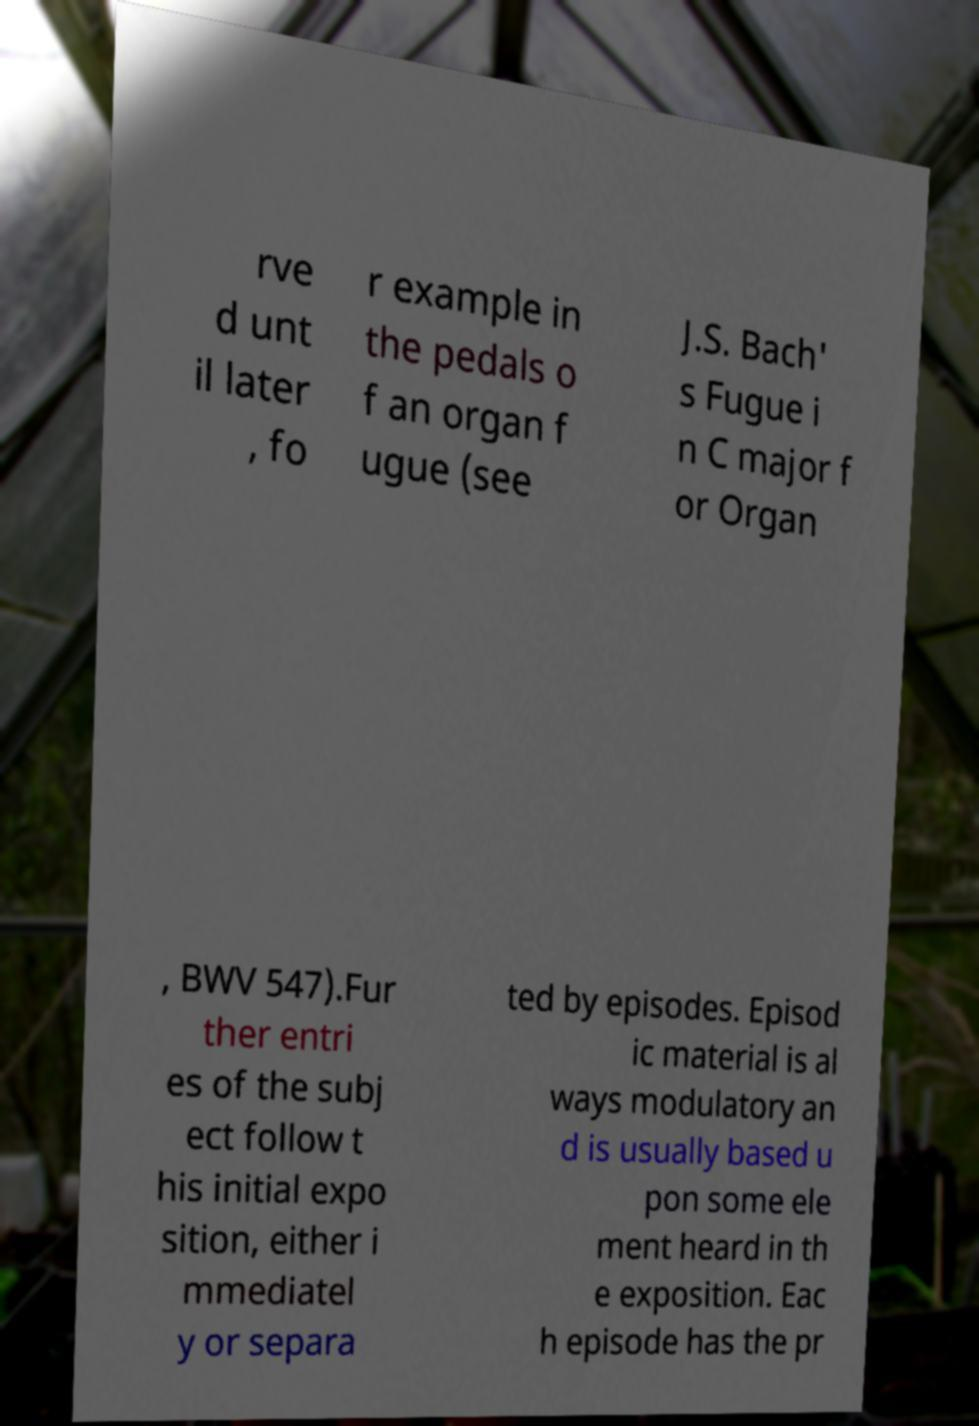Could you assist in decoding the text presented in this image and type it out clearly? rve d unt il later , fo r example in the pedals o f an organ f ugue (see J.S. Bach' s Fugue i n C major f or Organ , BWV 547).Fur ther entri es of the subj ect follow t his initial expo sition, either i mmediatel y or separa ted by episodes. Episod ic material is al ways modulatory an d is usually based u pon some ele ment heard in th e exposition. Eac h episode has the pr 